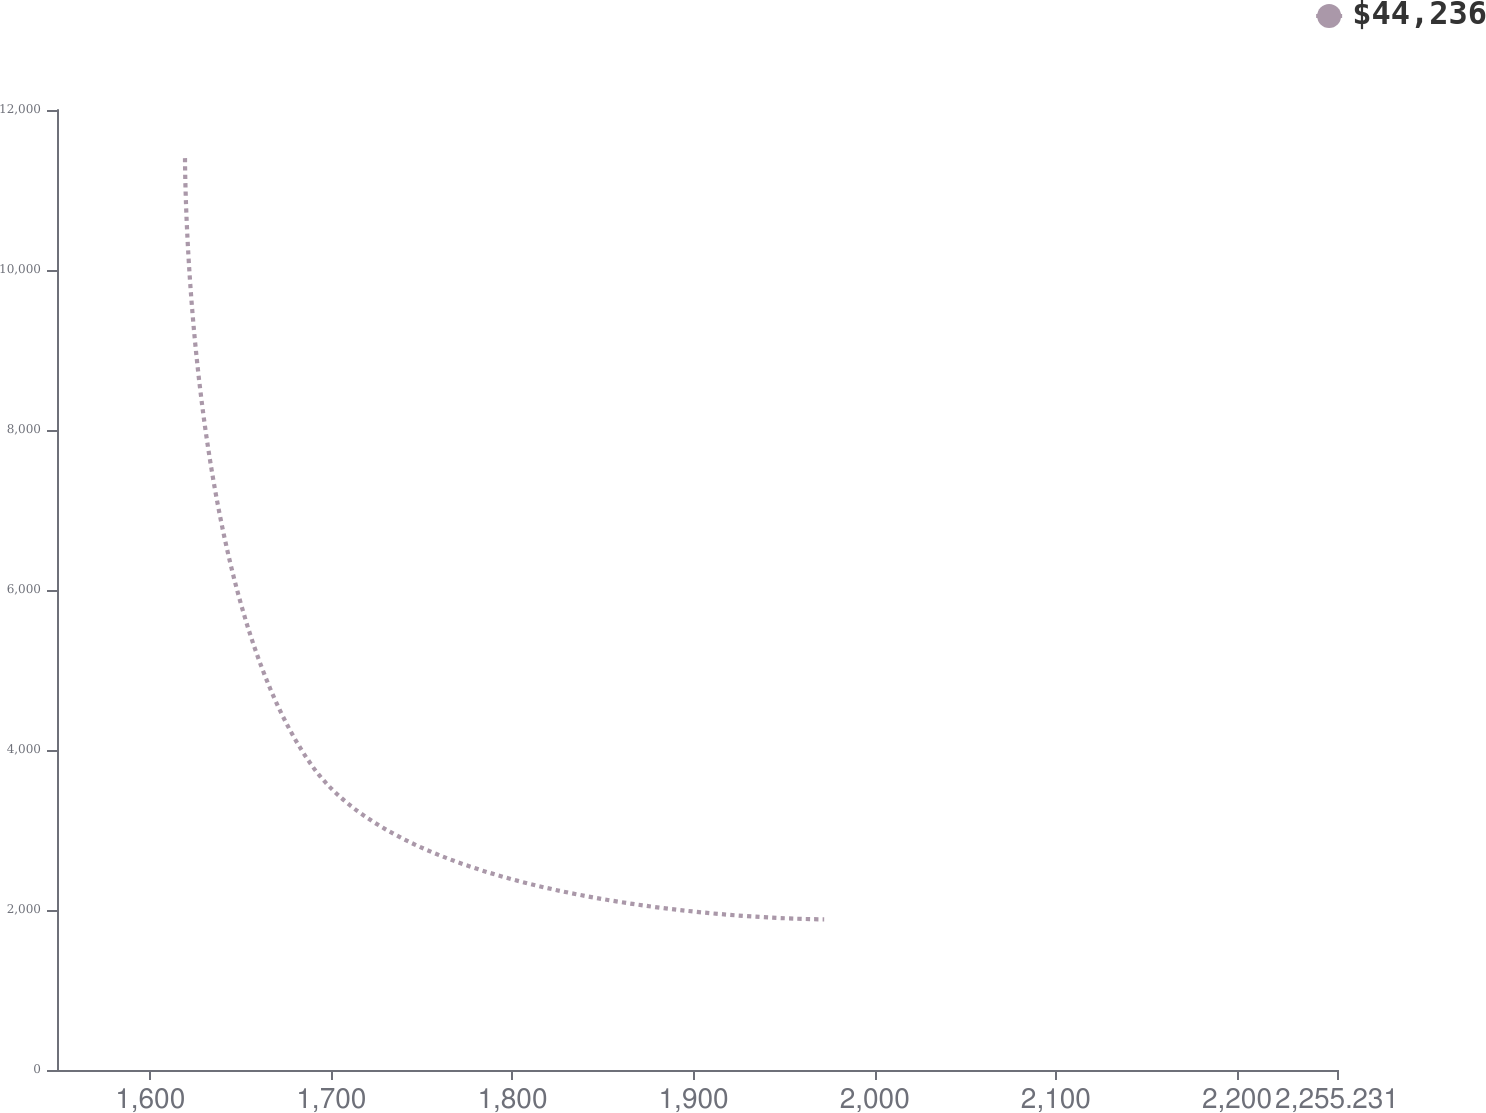Convert chart to OTSL. <chart><loc_0><loc_0><loc_500><loc_500><line_chart><ecel><fcel>$44,236<nl><fcel>1619.21<fcel>11398.4<nl><fcel>1689.88<fcel>3786.24<nl><fcel>1972.11<fcel>1883.2<nl><fcel>2325.9<fcel>2834.72<nl></chart> 